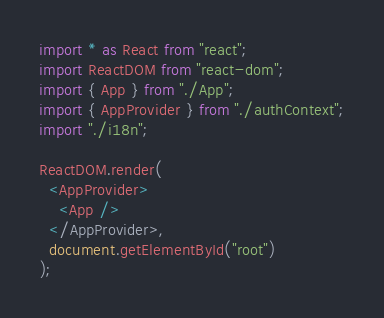Convert code to text. <code><loc_0><loc_0><loc_500><loc_500><_TypeScript_>import * as React from "react";
import ReactDOM from "react-dom";
import { App } from "./App";
import { AppProvider } from "./authContext";
import "./i18n";

ReactDOM.render(
  <AppProvider>
    <App />
  </AppProvider>,
  document.getElementById("root")
);
</code> 